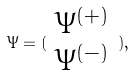<formula> <loc_0><loc_0><loc_500><loc_500>\Psi = ( \begin{array} { c } \Psi ^ { ( + ) } \\ \Psi ^ { ( - ) } \end{array} ) ,</formula> 